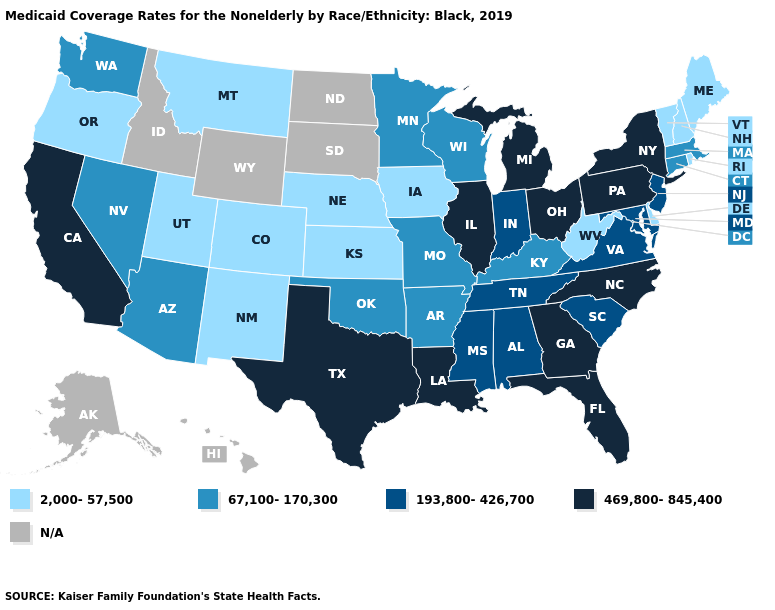Is the legend a continuous bar?
Keep it brief. No. What is the highest value in the USA?
Write a very short answer. 469,800-845,400. Which states have the lowest value in the Northeast?
Keep it brief. Maine, New Hampshire, Rhode Island, Vermont. Name the states that have a value in the range 2,000-57,500?
Quick response, please. Colorado, Delaware, Iowa, Kansas, Maine, Montana, Nebraska, New Hampshire, New Mexico, Oregon, Rhode Island, Utah, Vermont, West Virginia. How many symbols are there in the legend?
Answer briefly. 5. Among the states that border Indiana , which have the lowest value?
Be succinct. Kentucky. How many symbols are there in the legend?
Short answer required. 5. Does Virginia have the lowest value in the South?
Answer briefly. No. Does the map have missing data?
Give a very brief answer. Yes. What is the value of Mississippi?
Give a very brief answer. 193,800-426,700. Name the states that have a value in the range 67,100-170,300?
Short answer required. Arizona, Arkansas, Connecticut, Kentucky, Massachusetts, Minnesota, Missouri, Nevada, Oklahoma, Washington, Wisconsin. What is the highest value in the MidWest ?
Write a very short answer. 469,800-845,400. What is the highest value in the USA?
Write a very short answer. 469,800-845,400. Which states hav the highest value in the Northeast?
Give a very brief answer. New York, Pennsylvania. 